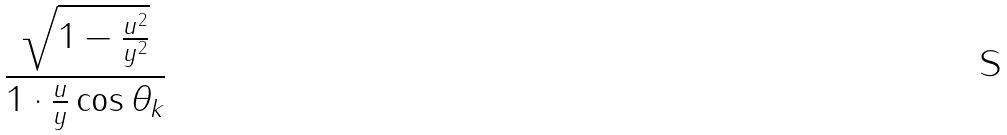<formula> <loc_0><loc_0><loc_500><loc_500>\frac { \sqrt { 1 - \frac { u ^ { 2 } } { y ^ { 2 } } } } { 1 \cdot \frac { u } { y } \cos \theta _ { k } }</formula> 